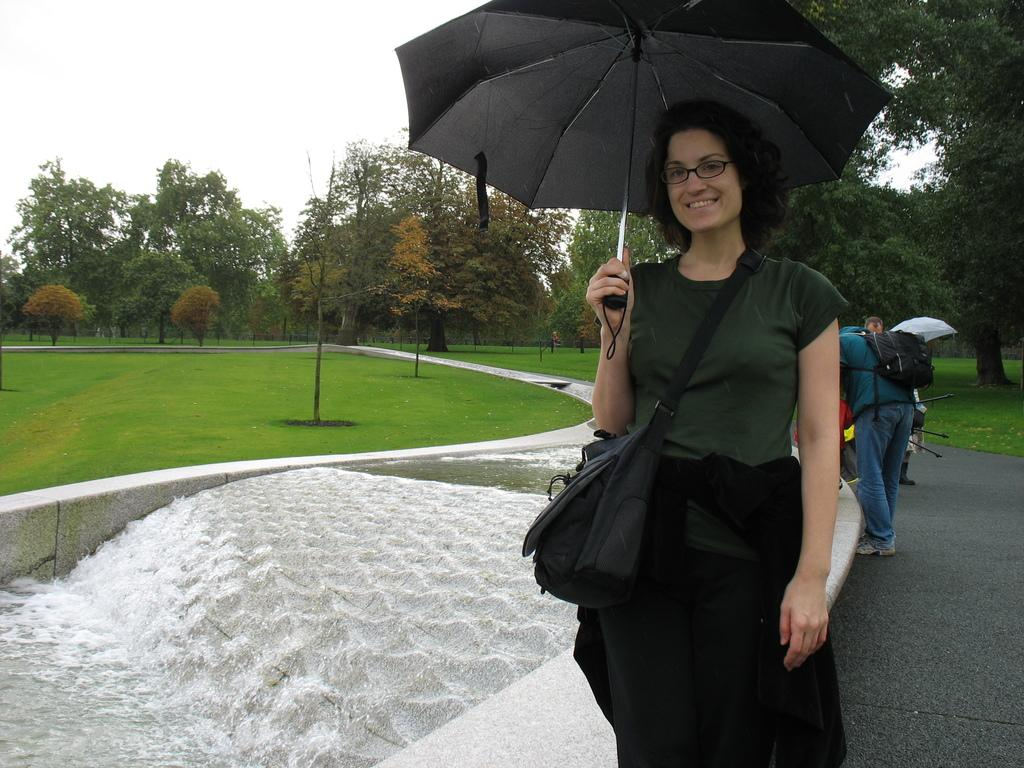What is the woman in the image doing? The woman is standing in the image. What is the woman wearing in the image? The woman is wearing a bag. What object is the woman holding in the image? The woman is holding a black umbrella. What can be seen in the background of the image? There are people, water, and trees visible in the background. What is the color of the sky in the image? The sky appears to be white in color. Can you tell me how many rays are visible in the image? There are no rays visible in the image. What type of earthquake can be seen in the image? There is no earthquake present in the image. 